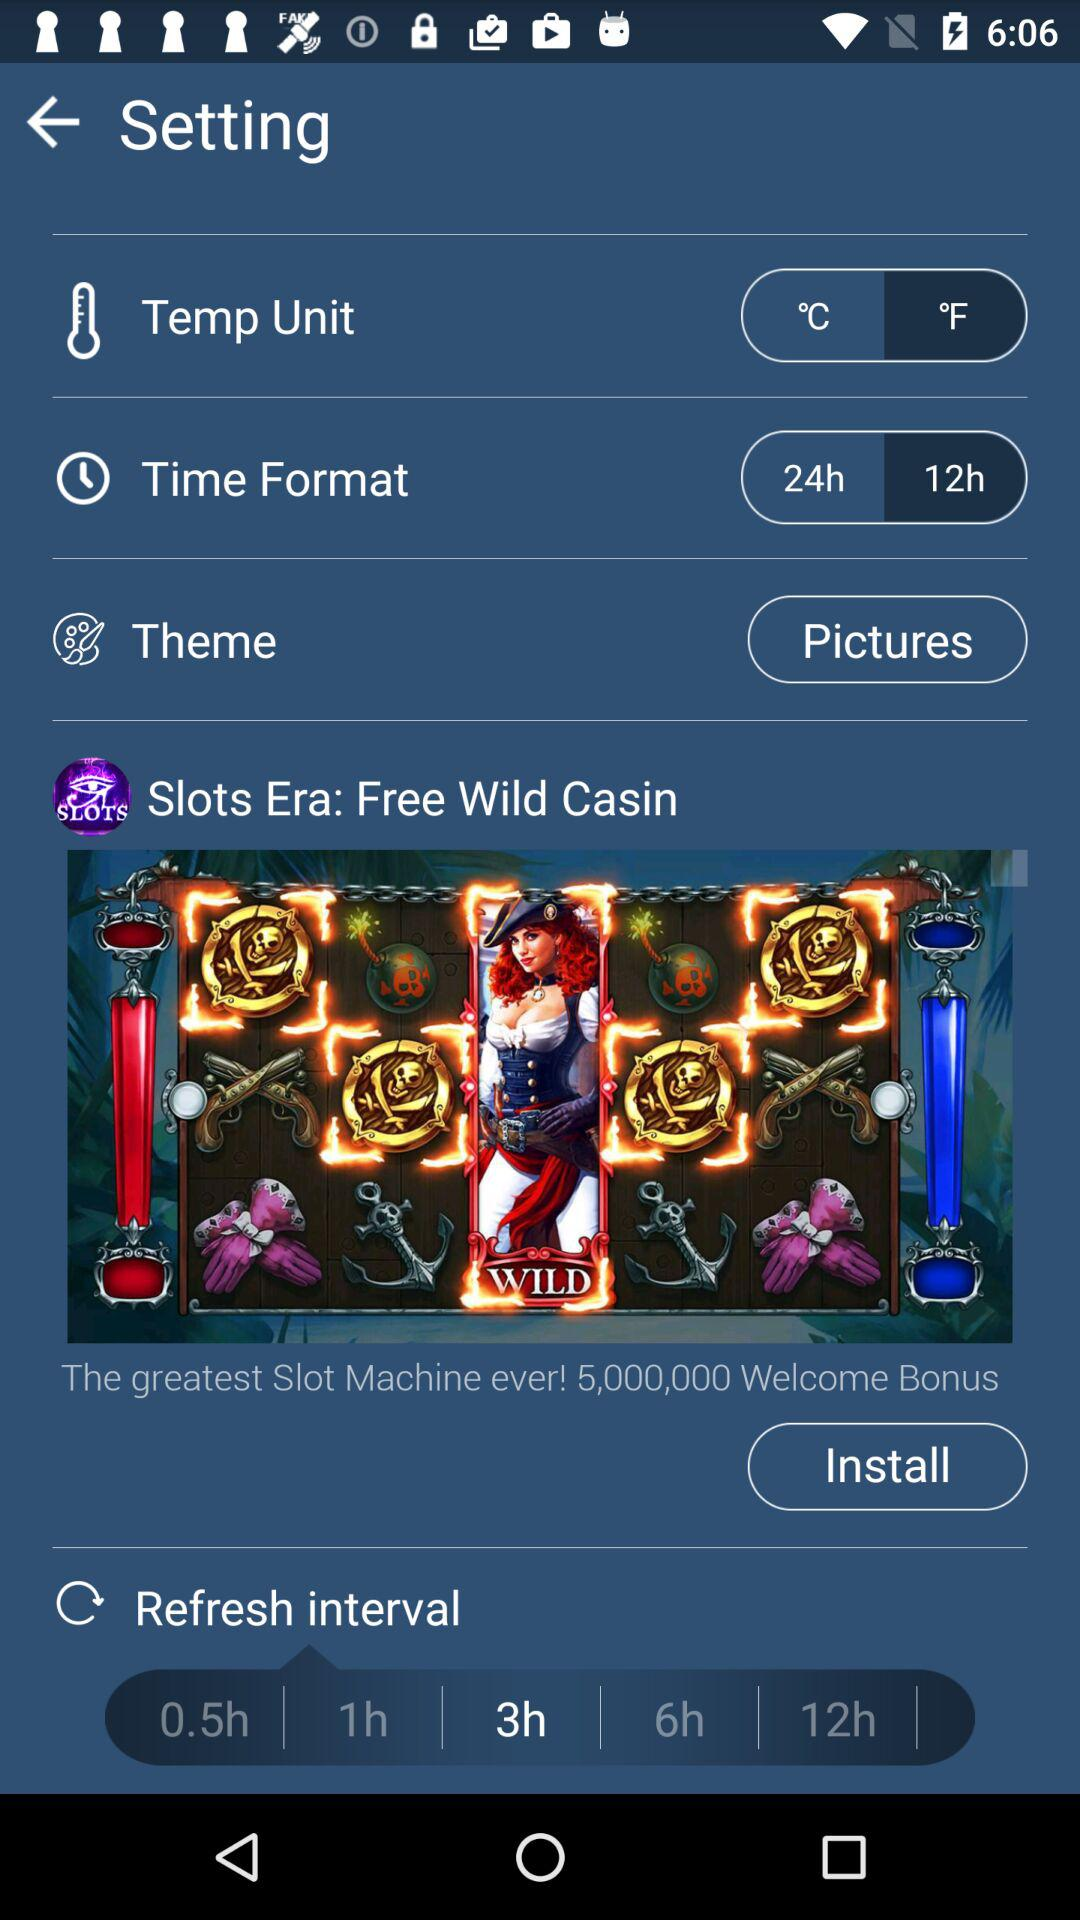What are the units of temperature? The units of temperature are Celsius and Fahrenheit. 